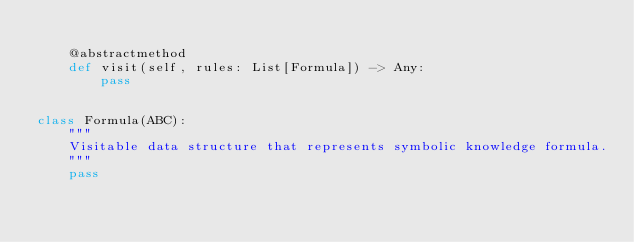Convert code to text. <code><loc_0><loc_0><loc_500><loc_500><_Python_>
    @abstractmethod
    def visit(self, rules: List[Formula]) -> Any:
        pass


class Formula(ABC):
    """
    Visitable data structure that represents symbolic knowledge formula.
    """
    pass
</code> 